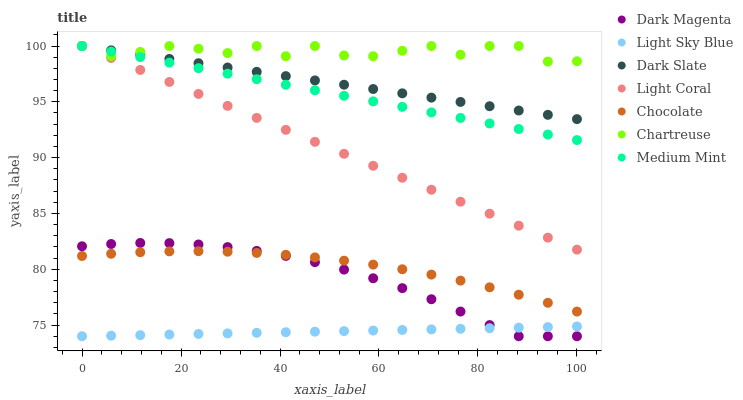Does Light Sky Blue have the minimum area under the curve?
Answer yes or no. Yes. Does Chartreuse have the maximum area under the curve?
Answer yes or no. Yes. Does Dark Magenta have the minimum area under the curve?
Answer yes or no. No. Does Dark Magenta have the maximum area under the curve?
Answer yes or no. No. Is Light Sky Blue the smoothest?
Answer yes or no. Yes. Is Chartreuse the roughest?
Answer yes or no. Yes. Is Dark Magenta the smoothest?
Answer yes or no. No. Is Dark Magenta the roughest?
Answer yes or no. No. Does Dark Magenta have the lowest value?
Answer yes or no. Yes. Does Chocolate have the lowest value?
Answer yes or no. No. Does Chartreuse have the highest value?
Answer yes or no. Yes. Does Dark Magenta have the highest value?
Answer yes or no. No. Is Dark Magenta less than Dark Slate?
Answer yes or no. Yes. Is Chartreuse greater than Light Sky Blue?
Answer yes or no. Yes. Does Dark Slate intersect Light Coral?
Answer yes or no. Yes. Is Dark Slate less than Light Coral?
Answer yes or no. No. Is Dark Slate greater than Light Coral?
Answer yes or no. No. Does Dark Magenta intersect Dark Slate?
Answer yes or no. No. 